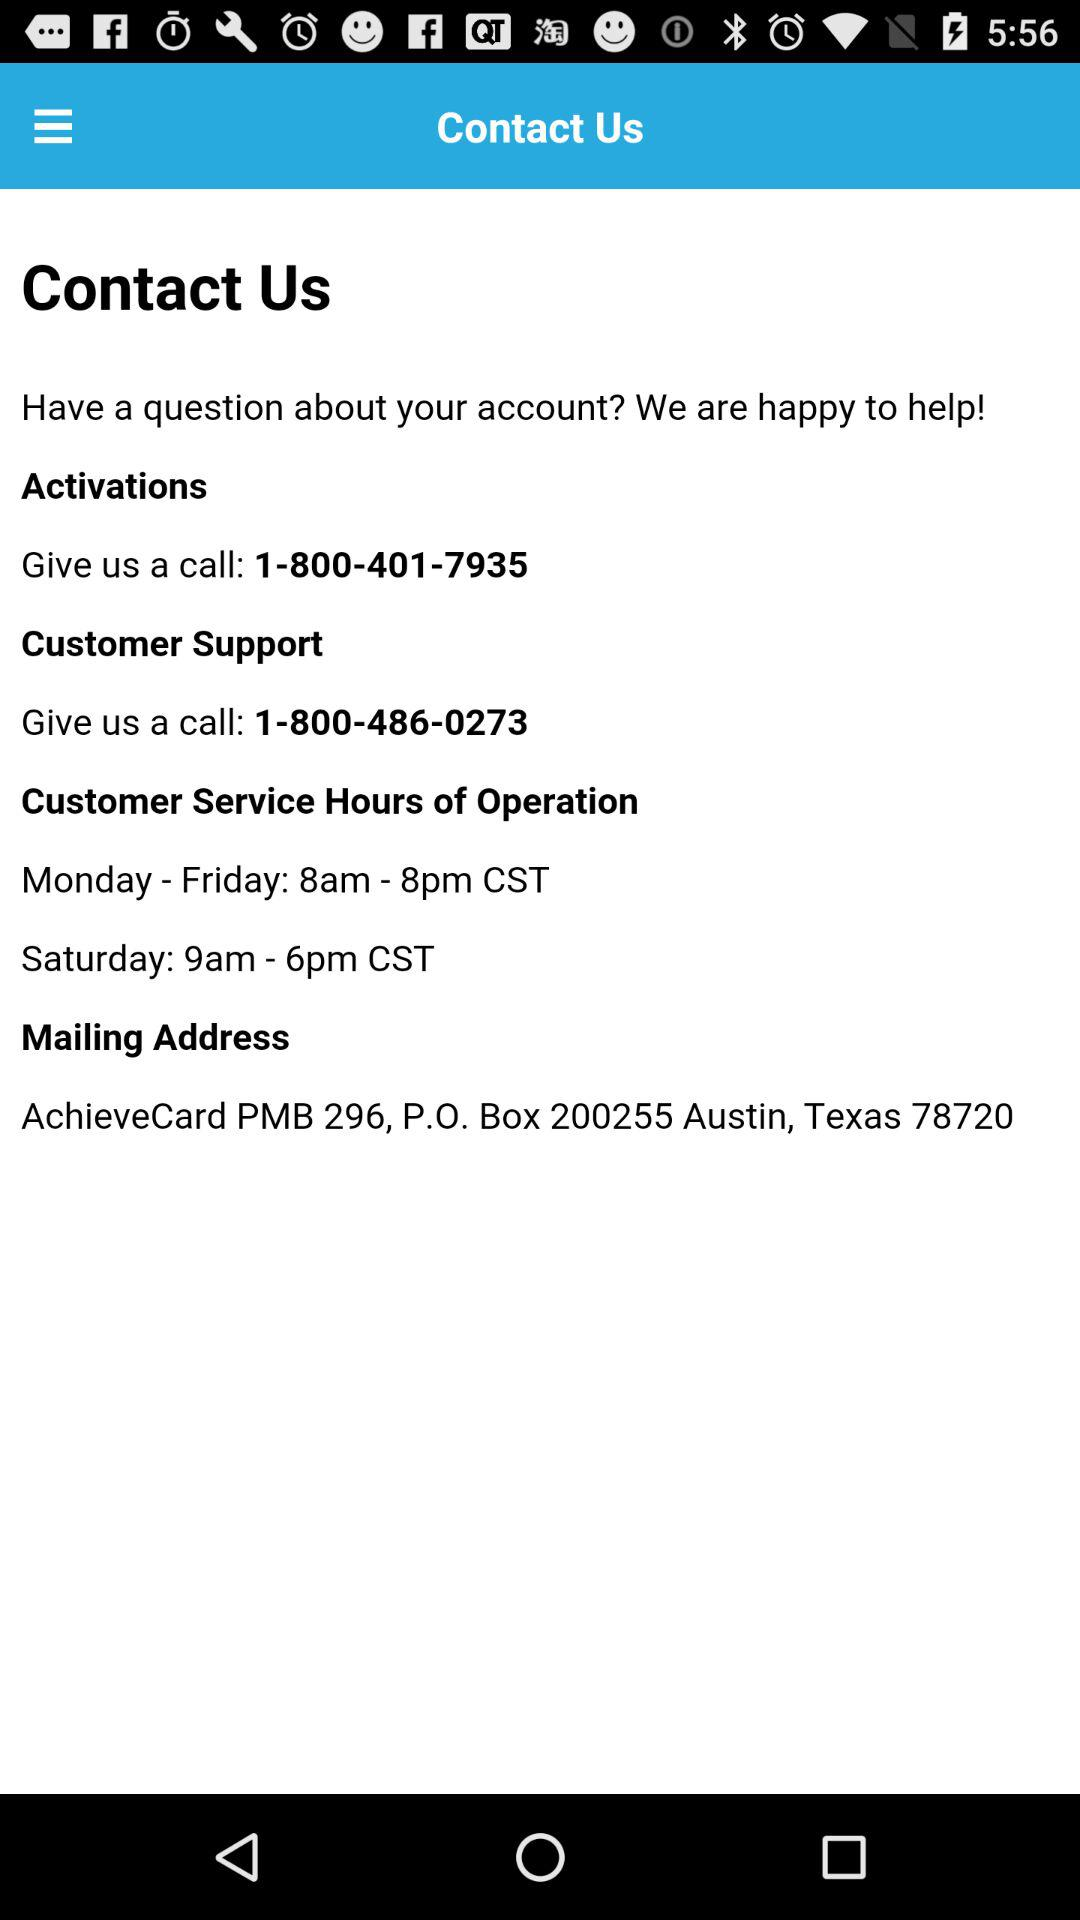What is the email address?
When the provided information is insufficient, respond with <no answer>. <no answer> 